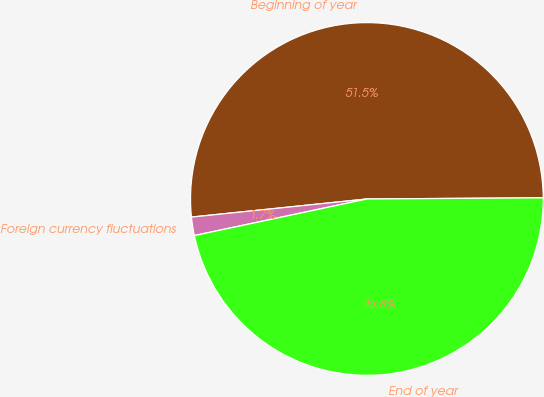<chart> <loc_0><loc_0><loc_500><loc_500><pie_chart><fcel>Beginning of year<fcel>Foreign currency fluctuations<fcel>End of year<nl><fcel>51.53%<fcel>1.69%<fcel>46.78%<nl></chart> 